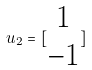Convert formula to latex. <formula><loc_0><loc_0><loc_500><loc_500>u _ { 2 } = [ \begin{matrix} 1 \\ - 1 \end{matrix} ]</formula> 